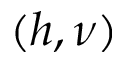<formula> <loc_0><loc_0><loc_500><loc_500>( h , \nu )</formula> 